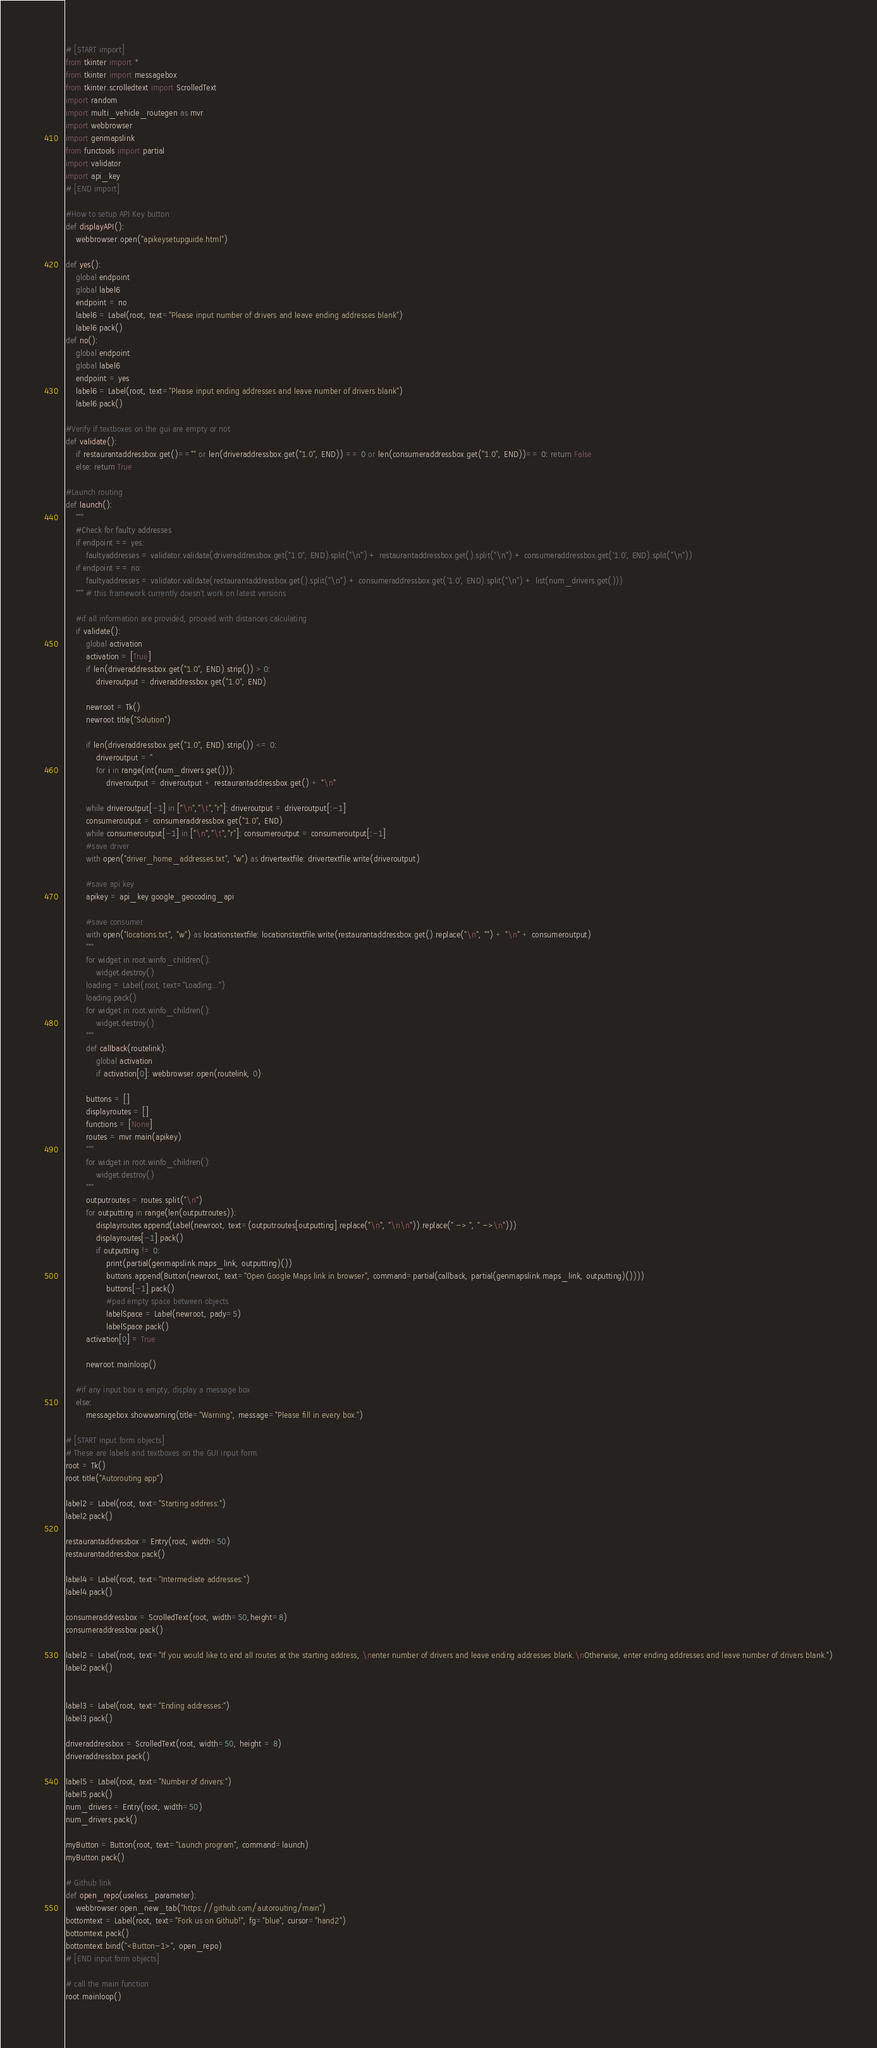<code> <loc_0><loc_0><loc_500><loc_500><_Python_># [START import]
from tkinter import *
from tkinter import messagebox
from tkinter.scrolledtext import ScrolledText
import random
import multi_vehicle_routegen as mvr
import webbrowser
import genmapslink
from functools import partial
import validator
import api_key
# [END import]

#How to setup API Key button
def displayAPI():
    webbrowser.open("apikeysetupguide.html")

def yes():
    global endpoint
    global label6
    endpoint = no
    label6 = Label(root, text="Please input number of drivers and leave ending addresses blank")
    label6.pack()
def no():
    global endpoint
    global label6
    endpoint = yes
    label6 = Label(root, text="Please input ending addresses and leave number of drivers blank")
    label6.pack()
    
#Verify if textboxes on the gui are empty or not
def validate():
    if restaurantaddressbox.get()=="" or len(driveraddressbox.get("1.0", END)) == 0 or len(consumeraddressbox.get("1.0", END))== 0: return False
    else: return True

#Launch routing 
def launch():
    """
    #Check for faulty addresses
    if endpoint == yes:
        faultyaddresses = validator.validate(driveraddressbox.get("1.0", END).split("\n") + restaurantaddressbox.get().split("\n") + consumeraddressbox.get('1.0', END).split("\n"))
    if endpoint == no:
        faultyaddresses = validator.validate(restaurantaddressbox.get().split("\n") + consumeraddressbox.get('1.0', END).split("\n") + list(num_drivers.get()))
    """ # this framework currently doesn't work on latest versions

    #if all information are provided, proceed with distances calculating
    if validate():
        global activation
        activation = [True]
        if len(driveraddressbox.get("1.0", END).strip()) > 0:
            driveroutput = driveraddressbox.get("1.0", END)

        newroot = Tk()
        newroot.title("Solution")

        if len(driveraddressbox.get("1.0", END).strip()) <= 0:
            driveroutput = ''
            for i in range(int(num_drivers.get())):
                driveroutput = driveroutput + restaurantaddressbox.get() + "\n"

        while driveroutput[-1] in ["\n","\t","r"]: driveroutput = driveroutput[:-1]
        consumeroutput = consumeraddressbox.get("1.0", END)
        while consumeroutput[-1] in ["\n","\t","r"]: consumeroutput = consumeroutput[:-1]
        #save driver
        with open("driver_home_addresses.txt", "w") as drivertextfile: drivertextfile.write(driveroutput)
        
        #save api key
        apikey = api_key.google_geocoding_api

        #save consumer
        with open("locations.txt", "w") as locationstextfile: locationstextfile.write(restaurantaddressbox.get().replace("\n", "") + "\n" + consumeroutput)
        """
        for widget in root.winfo_children():
            widget.destroy()
        loading = Label(root, text="Loading...")
        loading.pack()
        for widget in root.winfo_children():
            widget.destroy()
        """
        def callback(routelink):
            global activation
            if activation[0]: webbrowser.open(routelink, 0)

        buttons = []
        displayroutes = []
        functions = [None]
        routes = mvr.main(apikey)
        """
        for widget in root.winfo_children():
            widget.destroy()
        """
        outputroutes = routes.split("\n")
        for outputting in range(len(outputroutes)):
            displayroutes.append(Label(newroot, text=(outputroutes[outputting].replace("\n", "\n\n")).replace(" -> ", " ->\n")))
            displayroutes[-1].pack()
            if outputting != 0:
                print(partial(genmapslink.maps_link, outputting)())
                buttons.append(Button(newroot, text="Open Google Maps link in browser", command=partial(callback, partial(genmapslink.maps_link, outputting)())))
                buttons[-1].pack()
                #pad empty space between objects
                labelSpace = Label(newroot, pady=5)
                labelSpace.pack()
        activation[0] = True

        newroot.mainloop()
            
    #if any input box is empty, display a message box     
    else:
        messagebox.showwarning(title="Warning", message="Please fill in every box.")

# [START input form objects]
# These are labels and textboxes on the GUI input form.
root = Tk()
root.title("Autorouting app")

label2 = Label(root, text="Starting address:")
label2.pack()

restaurantaddressbox = Entry(root, width=50)
restaurantaddressbox.pack()

label4 = Label(root, text="Intermediate addresses:")
label4.pack()

consumeraddressbox = ScrolledText(root, width=50,height=8)
consumeraddressbox.pack()

label2 = Label(root, text="If you would like to end all routes at the starting address, \nenter number of drivers and leave ending addresses blank.\nOtherwise, enter ending addresses and leave number of drivers blank.")
label2.pack()


label3 = Label(root, text="Ending addresses:")
label3.pack()

driveraddressbox = ScrolledText(root, width=50, height = 8)
driveraddressbox.pack()

label5 = Label(root, text="Number of drivers:")
label5.pack()
num_drivers = Entry(root, width=50)
num_drivers.pack()

myButton = Button(root, text="Launch program", command=launch)
myButton.pack()

# Github link
def open_repo(useless_parameter):
    webbrowser.open_new_tab("https://github.com/autorouting/main")
bottomtext = Label(root, text="Fork us on Github!", fg="blue", cursor="hand2")
bottomtext.pack()
bottomtext.bind("<Button-1>", open_repo)
# [END input form objects]

# call the main function
root.mainloop()
</code> 